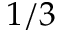Convert formula to latex. <formula><loc_0><loc_0><loc_500><loc_500>1 / 3</formula> 